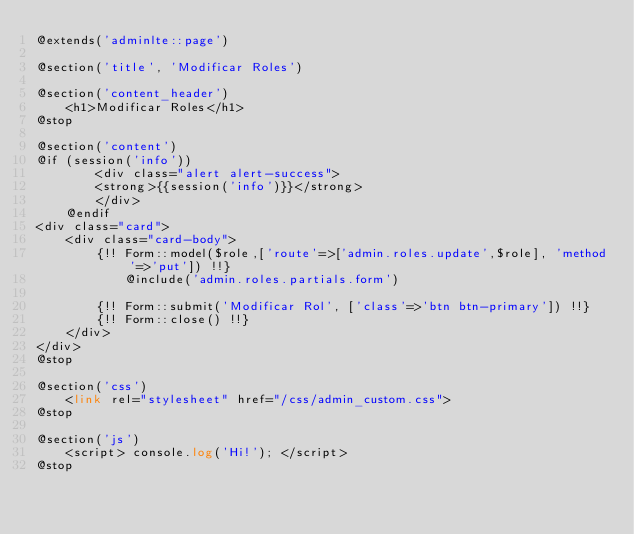Convert code to text. <code><loc_0><loc_0><loc_500><loc_500><_PHP_>@extends('adminlte::page')

@section('title', 'Modificar Roles')

@section('content_header')
    <h1>Modificar Roles</h1>
@stop

@section('content')
@if (session('info'))
        <div class="alert alert-success">
        <strong>{{session('info')}}</strong>
        </div>   
    @endif
<div class="card">
    <div class="card-body">
        {!! Form::model($role,['route'=>['admin.roles.update',$role], 'method'=>'put']) !!}
            @include('admin.roles.partials.form')

        {!! Form::submit('Modificar Rol', ['class'=>'btn btn-primary']) !!}
        {!! Form::close() !!}
    </div>
</div>
@stop

@section('css')
    <link rel="stylesheet" href="/css/admin_custom.css">
@stop

@section('js')
    <script> console.log('Hi!'); </script>
@stop</code> 